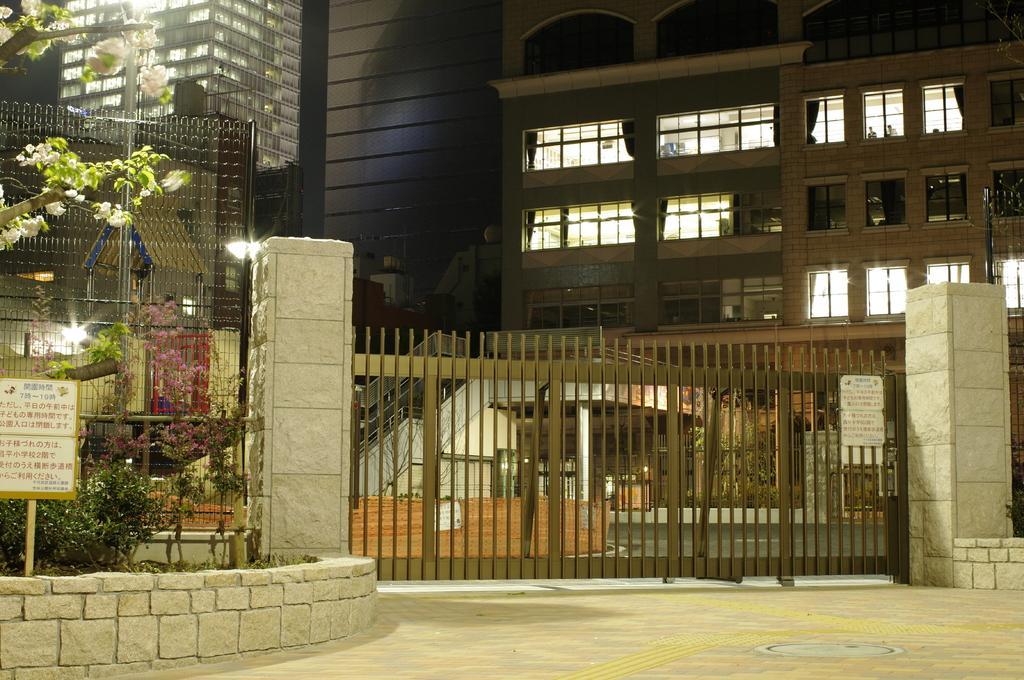In one or two sentences, can you explain what this image depicts? In this picture I can see some buildings, fencing, trees and gate to the wall. 